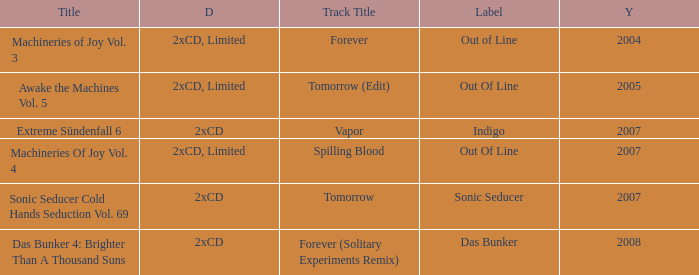Which details has the out of line label and the year of 2005? 2xCD, Limited. 